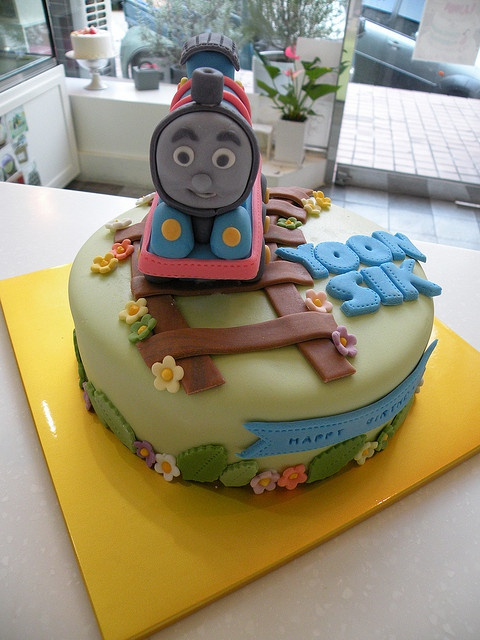Describe the objects in this image and their specific colors. I can see cake in black, gray, and olive tones, train in black, gray, blue, and brown tones, car in black, gray, and white tones, and potted plant in black, darkgray, gray, and darkgreen tones in this image. 